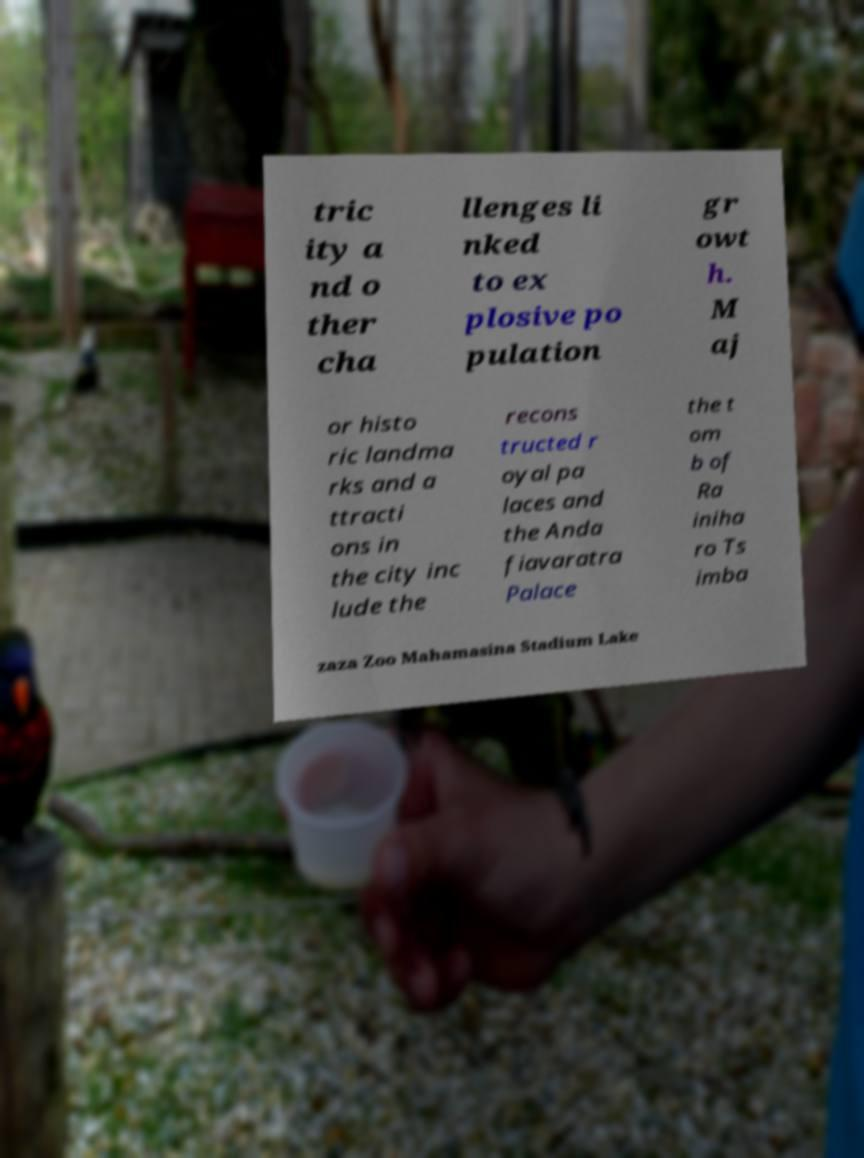There's text embedded in this image that I need extracted. Can you transcribe it verbatim? tric ity a nd o ther cha llenges li nked to ex plosive po pulation gr owt h. M aj or histo ric landma rks and a ttracti ons in the city inc lude the recons tructed r oyal pa laces and the Anda fiavaratra Palace the t om b of Ra iniha ro Ts imba zaza Zoo Mahamasina Stadium Lake 